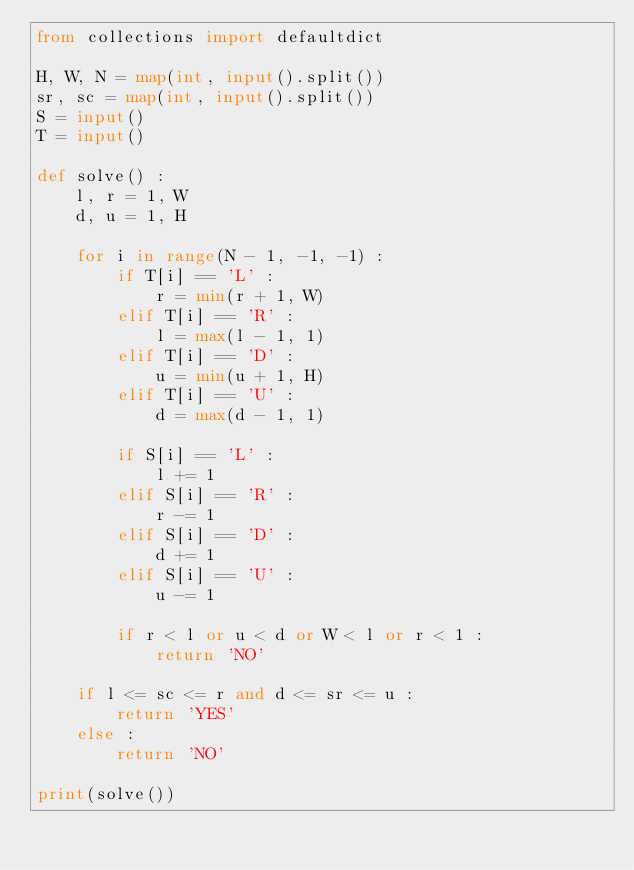Convert code to text. <code><loc_0><loc_0><loc_500><loc_500><_Python_>from collections import defaultdict

H, W, N = map(int, input().split())
sr, sc = map(int, input().split())
S = input()
T = input()

def solve() :
    l, r = 1, W
    d, u = 1, H
    
    for i in range(N - 1, -1, -1) :
        if T[i] == 'L' :
            r = min(r + 1, W)
        elif T[i] == 'R' :
            l = max(l - 1, 1)
        elif T[i] == 'D' :
            u = min(u + 1, H)
        elif T[i] == 'U' :
            d = max(d - 1, 1)
            
        if S[i] == 'L' :
            l += 1
        elif S[i] == 'R' :
            r -= 1
        elif S[i] == 'D' :
            d += 1
        elif S[i] == 'U' :
            u -= 1
            
        if r < l or u < d or W < l or r < 1 :
            return 'NO'

    if l <= sc <= r and d <= sr <= u :
        return 'YES'
    else :
        return 'NO'
    
print(solve())</code> 